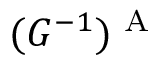<formula> <loc_0><loc_0><loc_500><loc_500>( G ^ { - 1 } ) ^ { A }</formula> 